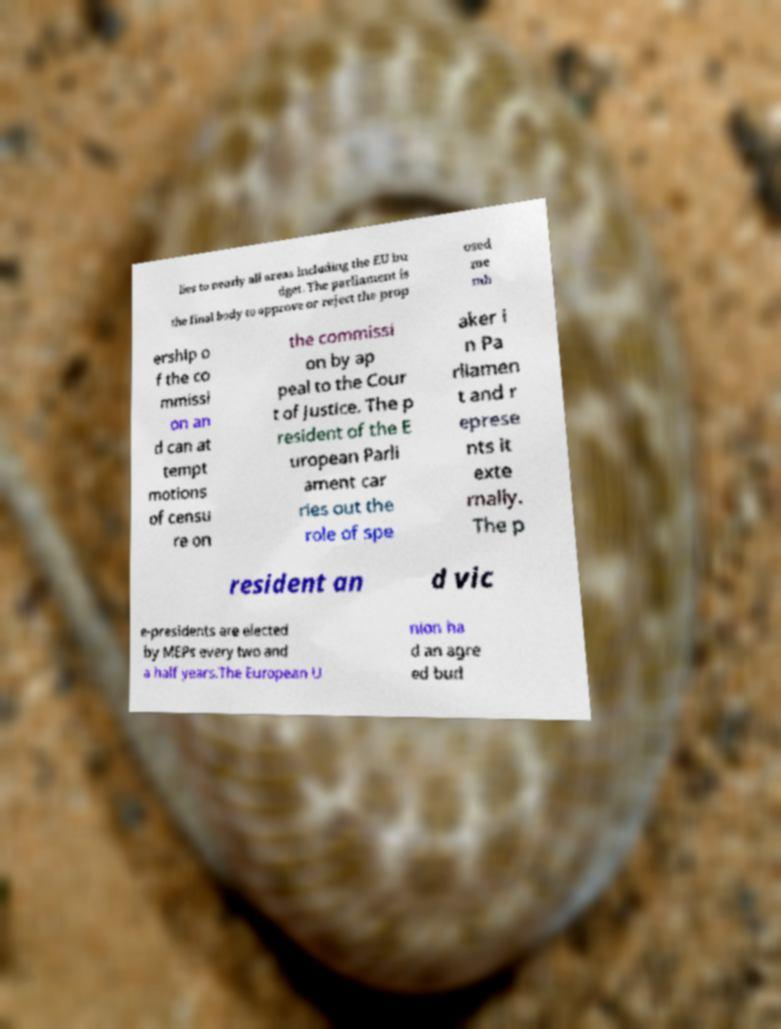For documentation purposes, I need the text within this image transcribed. Could you provide that? lies to nearly all areas including the EU bu dget. The parliament is the final body to approve or reject the prop osed me mb ership o f the co mmissi on an d can at tempt motions of censu re on the commissi on by ap peal to the Cour t of Justice. The p resident of the E uropean Parli ament car ries out the role of spe aker i n Pa rliamen t and r eprese nts it exte rnally. The p resident an d vic e-presidents are elected by MEPs every two and a half years.The European U nion ha d an agre ed bud 